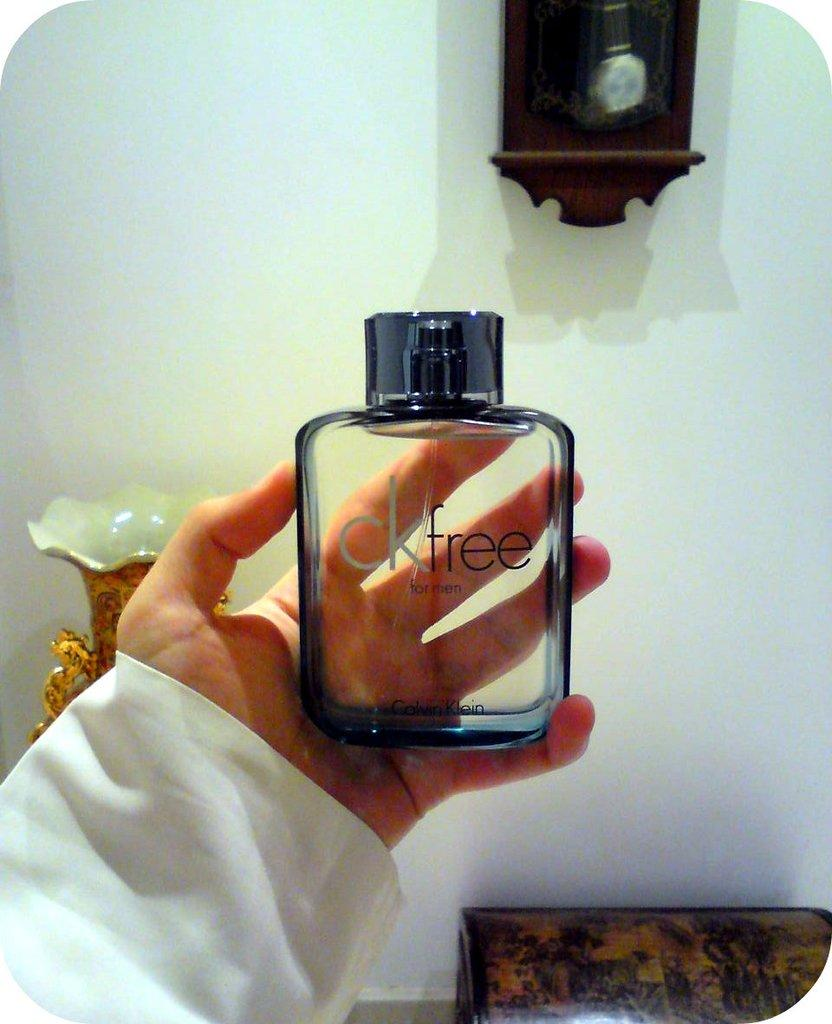<image>
Render a clear and concise summary of the photo. A person holding a botlle of CK Free for men. 